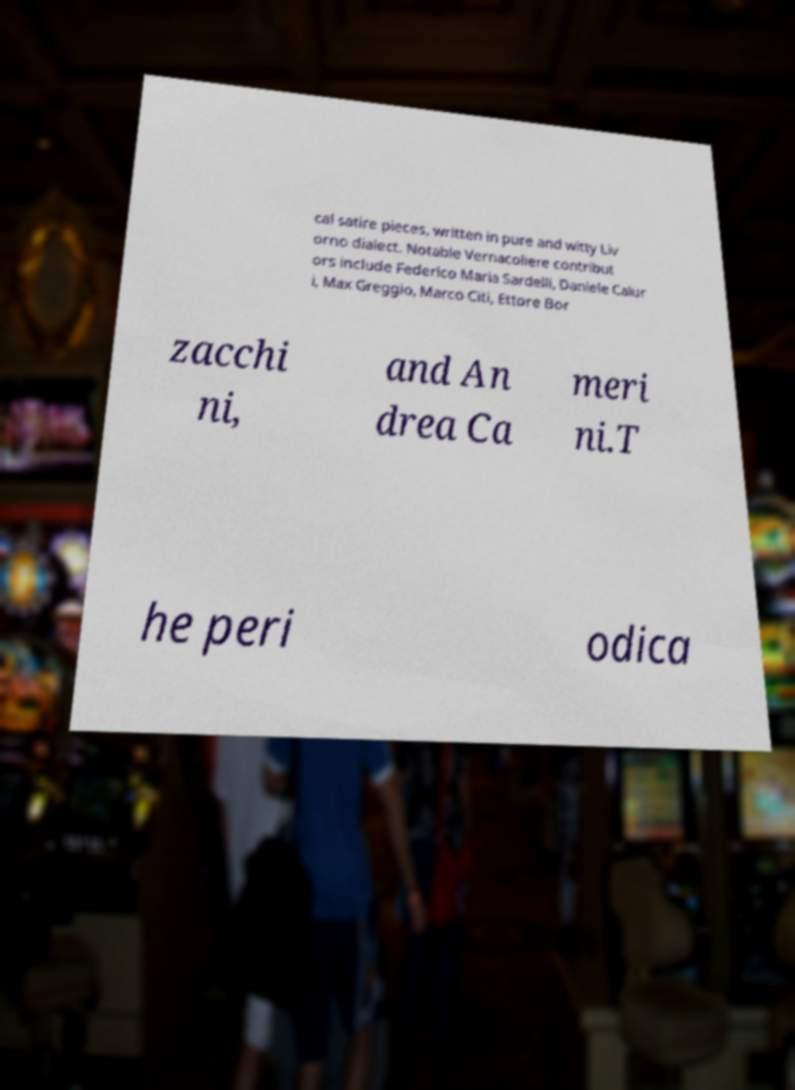Please read and relay the text visible in this image. What does it say? cal satire pieces, written in pure and witty Liv orno dialect. Notable Vernacoliere contribut ors include Federico Maria Sardelli, Daniele Calur i, Max Greggio, Marco Citi, Ettore Bor zacchi ni, and An drea Ca meri ni.T he peri odica 